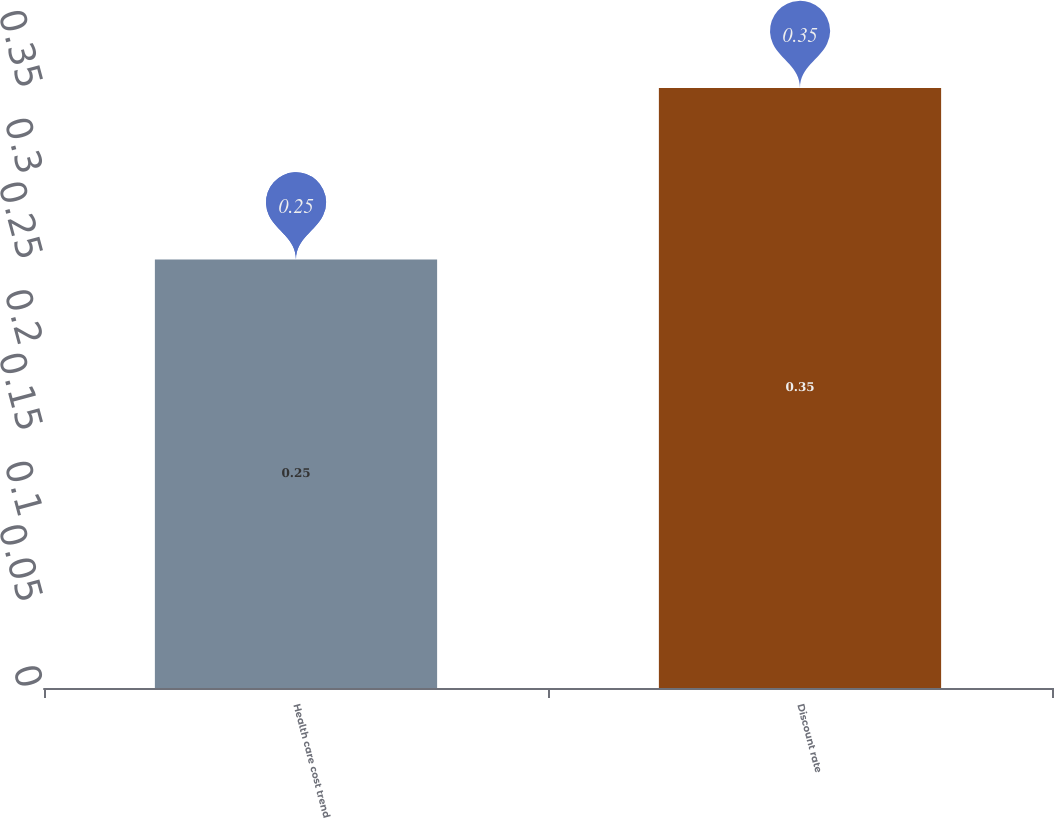<chart> <loc_0><loc_0><loc_500><loc_500><bar_chart><fcel>Health care cost trend<fcel>Discount rate<nl><fcel>0.25<fcel>0.35<nl></chart> 